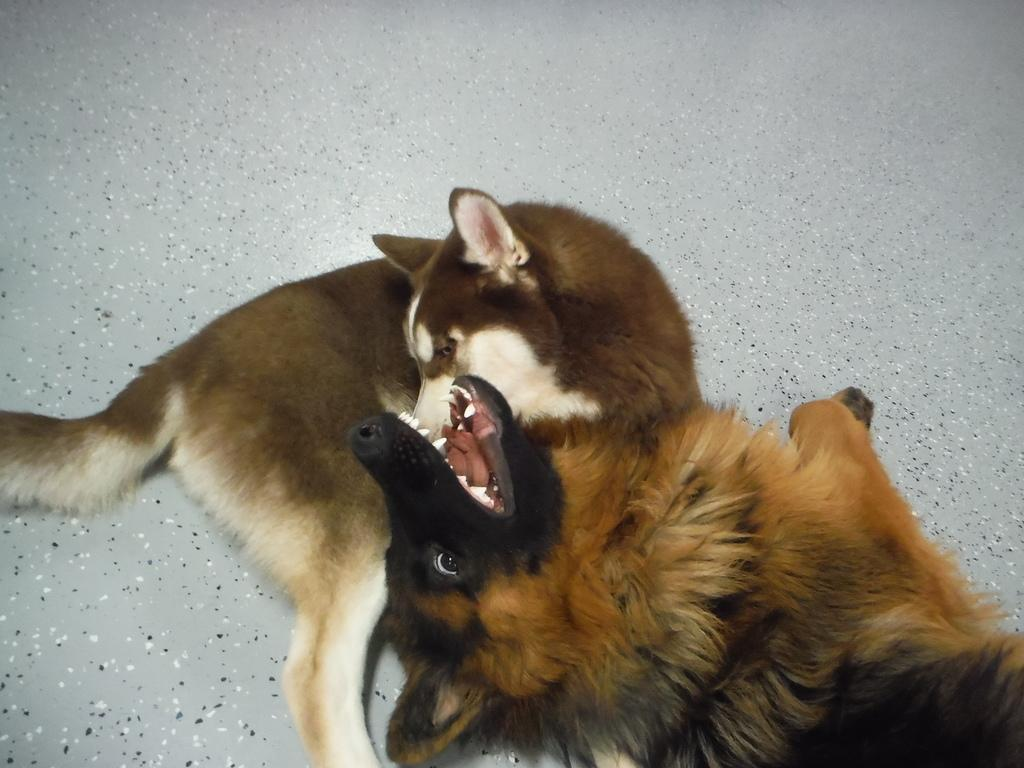How many dogs are present in the image? There are two dogs in the image. What are the dogs doing in the image? The dogs are laying down. What type of surface is visible in the image? There is a floor visible in the image. What type of joke is the dog telling in the image? There is no joke being told in the image; the dogs are simply laying down. How many fangs can be seen on the dogs in the image? The number of fangs cannot be determined from the image, as it only shows the dogs laying down and does not provide a clear view of their teeth. 